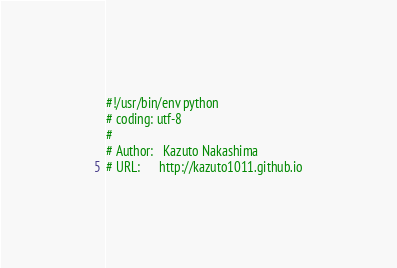Convert code to text. <code><loc_0><loc_0><loc_500><loc_500><_Python_>#!/usr/bin/env python
# coding: utf-8
#
# Author:   Kazuto Nakashima
# URL:      http://kazuto1011.github.io</code> 